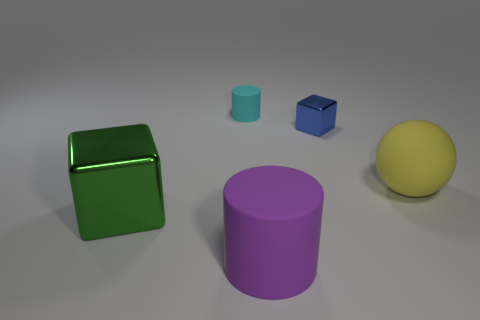What is the size of the cyan matte cylinder?
Your answer should be very brief. Small. Is the object in front of the green metallic block made of the same material as the large yellow thing?
Provide a short and direct response. Yes. Is the number of purple matte cylinders that are on the left side of the small cyan rubber cylinder less than the number of large objects that are to the left of the green metallic cube?
Provide a succinct answer. No. How many other objects are the same material as the blue block?
Make the answer very short. 1. There is a cyan cylinder that is the same size as the blue object; what is its material?
Offer a very short reply. Rubber. Are there fewer yellow rubber spheres behind the big metal block than matte balls?
Provide a succinct answer. No. There is a metal thing that is behind the metal cube in front of the large object that is behind the green metal object; what shape is it?
Give a very brief answer. Cube. There is a cube that is behind the big green metallic block; what is its size?
Ensure brevity in your answer.  Small. What shape is the green object that is the same size as the yellow matte object?
Offer a very short reply. Cube. How many things are either big things or matte objects that are behind the large rubber ball?
Give a very brief answer. 4. 